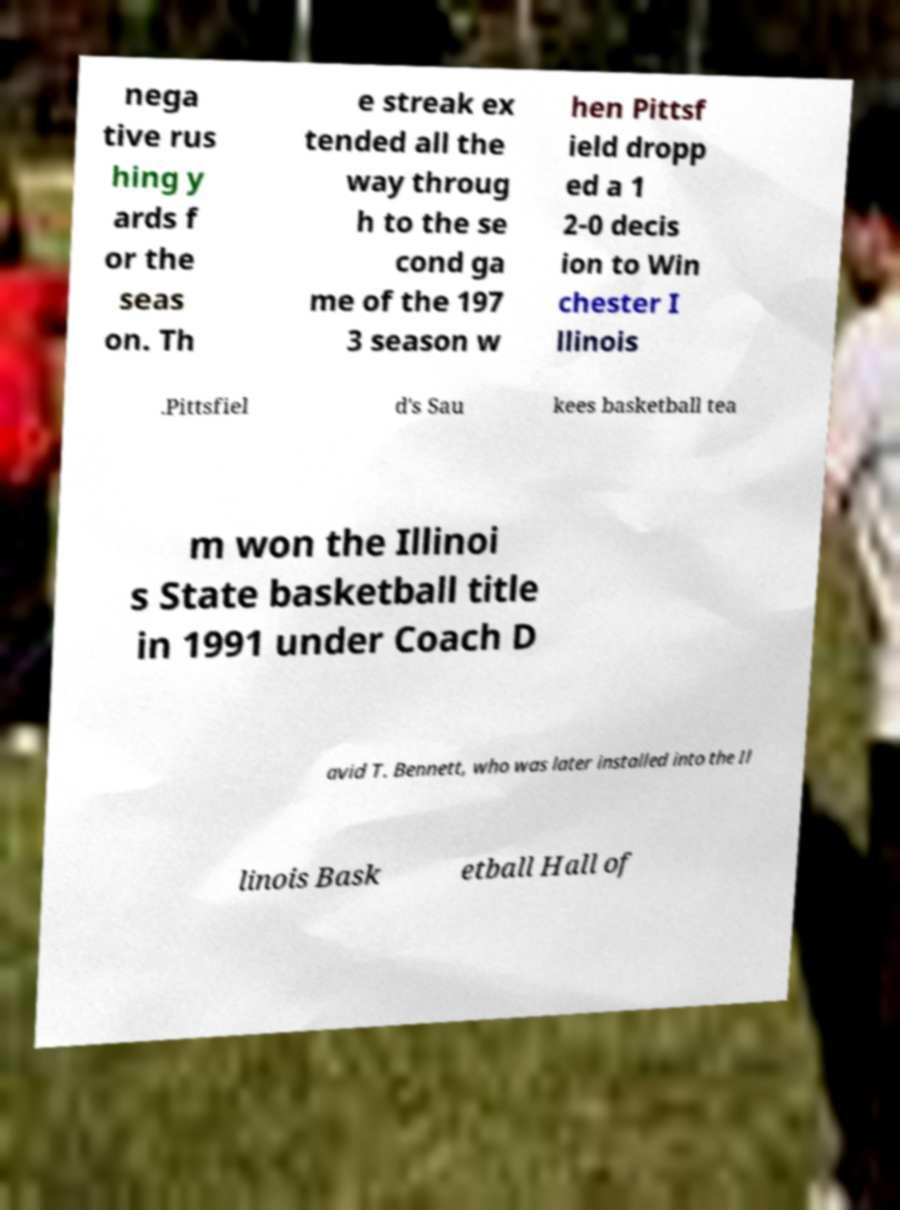Could you extract and type out the text from this image? nega tive rus hing y ards f or the seas on. Th e streak ex tended all the way throug h to the se cond ga me of the 197 3 season w hen Pittsf ield dropp ed a 1 2-0 decis ion to Win chester I llinois .Pittsfiel d's Sau kees basketball tea m won the Illinoi s State basketball title in 1991 under Coach D avid T. Bennett, who was later installed into the Il linois Bask etball Hall of 